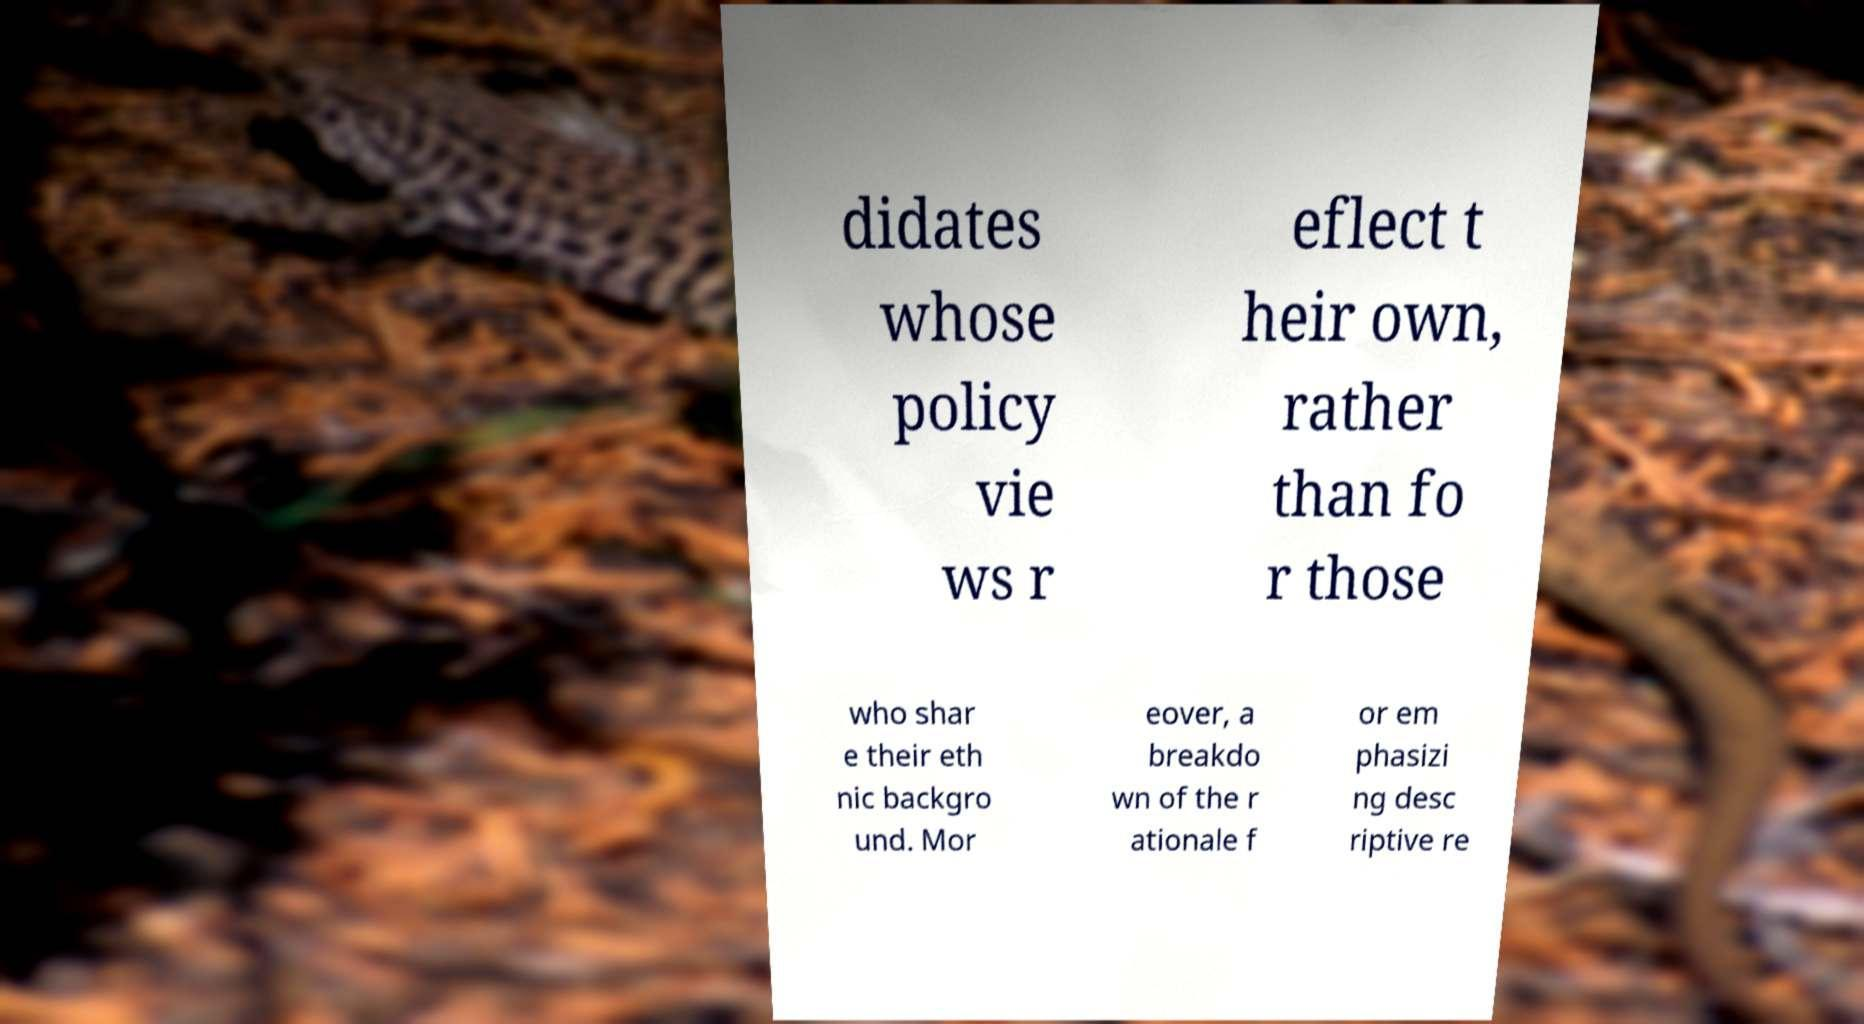There's text embedded in this image that I need extracted. Can you transcribe it verbatim? didates whose policy vie ws r eflect t heir own, rather than fo r those who shar e their eth nic backgro und. Mor eover, a breakdo wn of the r ationale f or em phasizi ng desc riptive re 